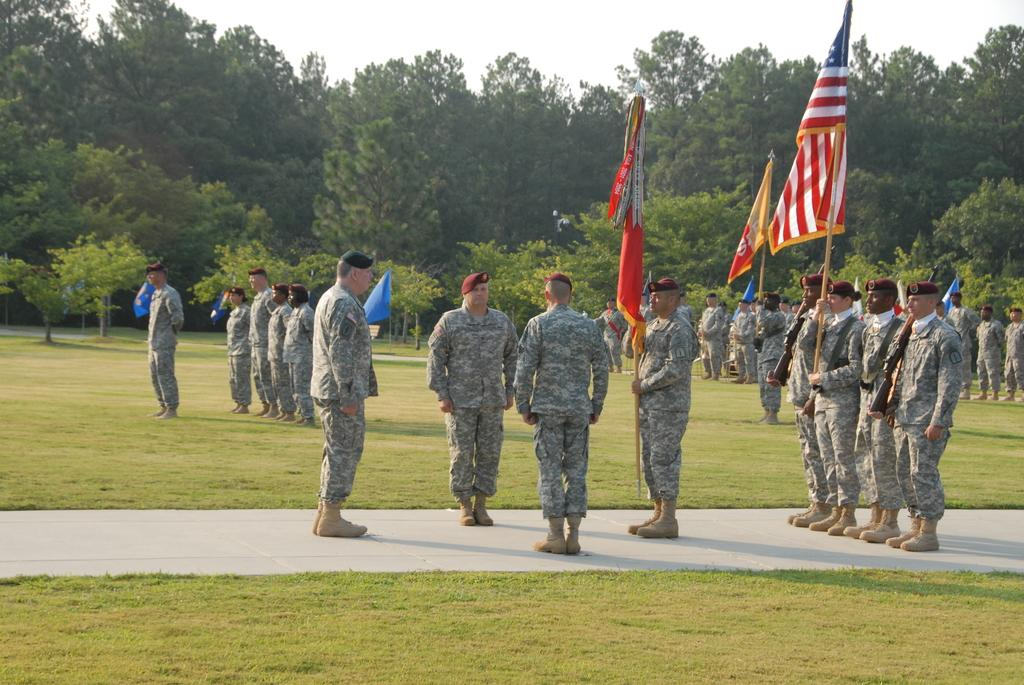What are the people in the image doing? The people in the image are standing on a walkway. What are some people holding in the image? Some people are holding flags in the image. What type of vegetation is visible in the image? There is green grass visible in the image. What can be seen in the background of the image? Trees are present in the background of the image. What is the condition of the sky in the image? The sky is clear in the image. What type of cloth is being used to cover the coach in the image? There is no coach or cloth present in the image. 